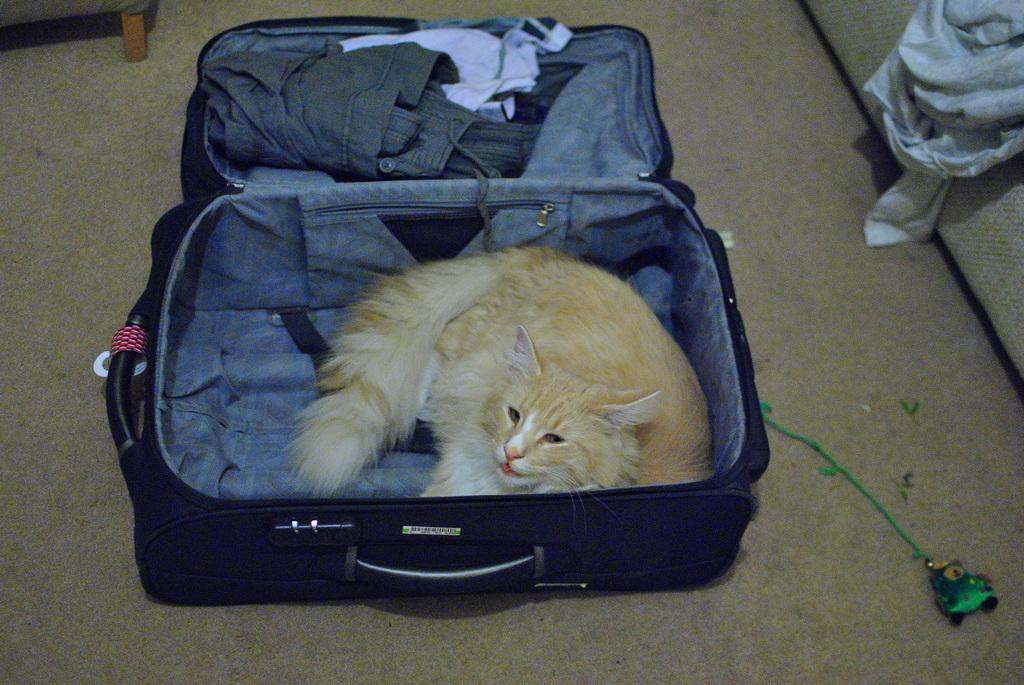What is the main object in the center of the image? There is a suitcase in the center of the image. What is inside the suitcase? A cat is present inside the suitcase. What else can be seen inside the suitcase besides the cat? There are clothes visible inside the suitcase. What is the rate of the dress in the image? There is no dress present in the image, so it is not possible to determine a rate. 